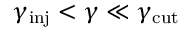Convert formula to latex. <formula><loc_0><loc_0><loc_500><loc_500>\gamma _ { i n j } < \gamma \ll \gamma _ { c u t }</formula> 